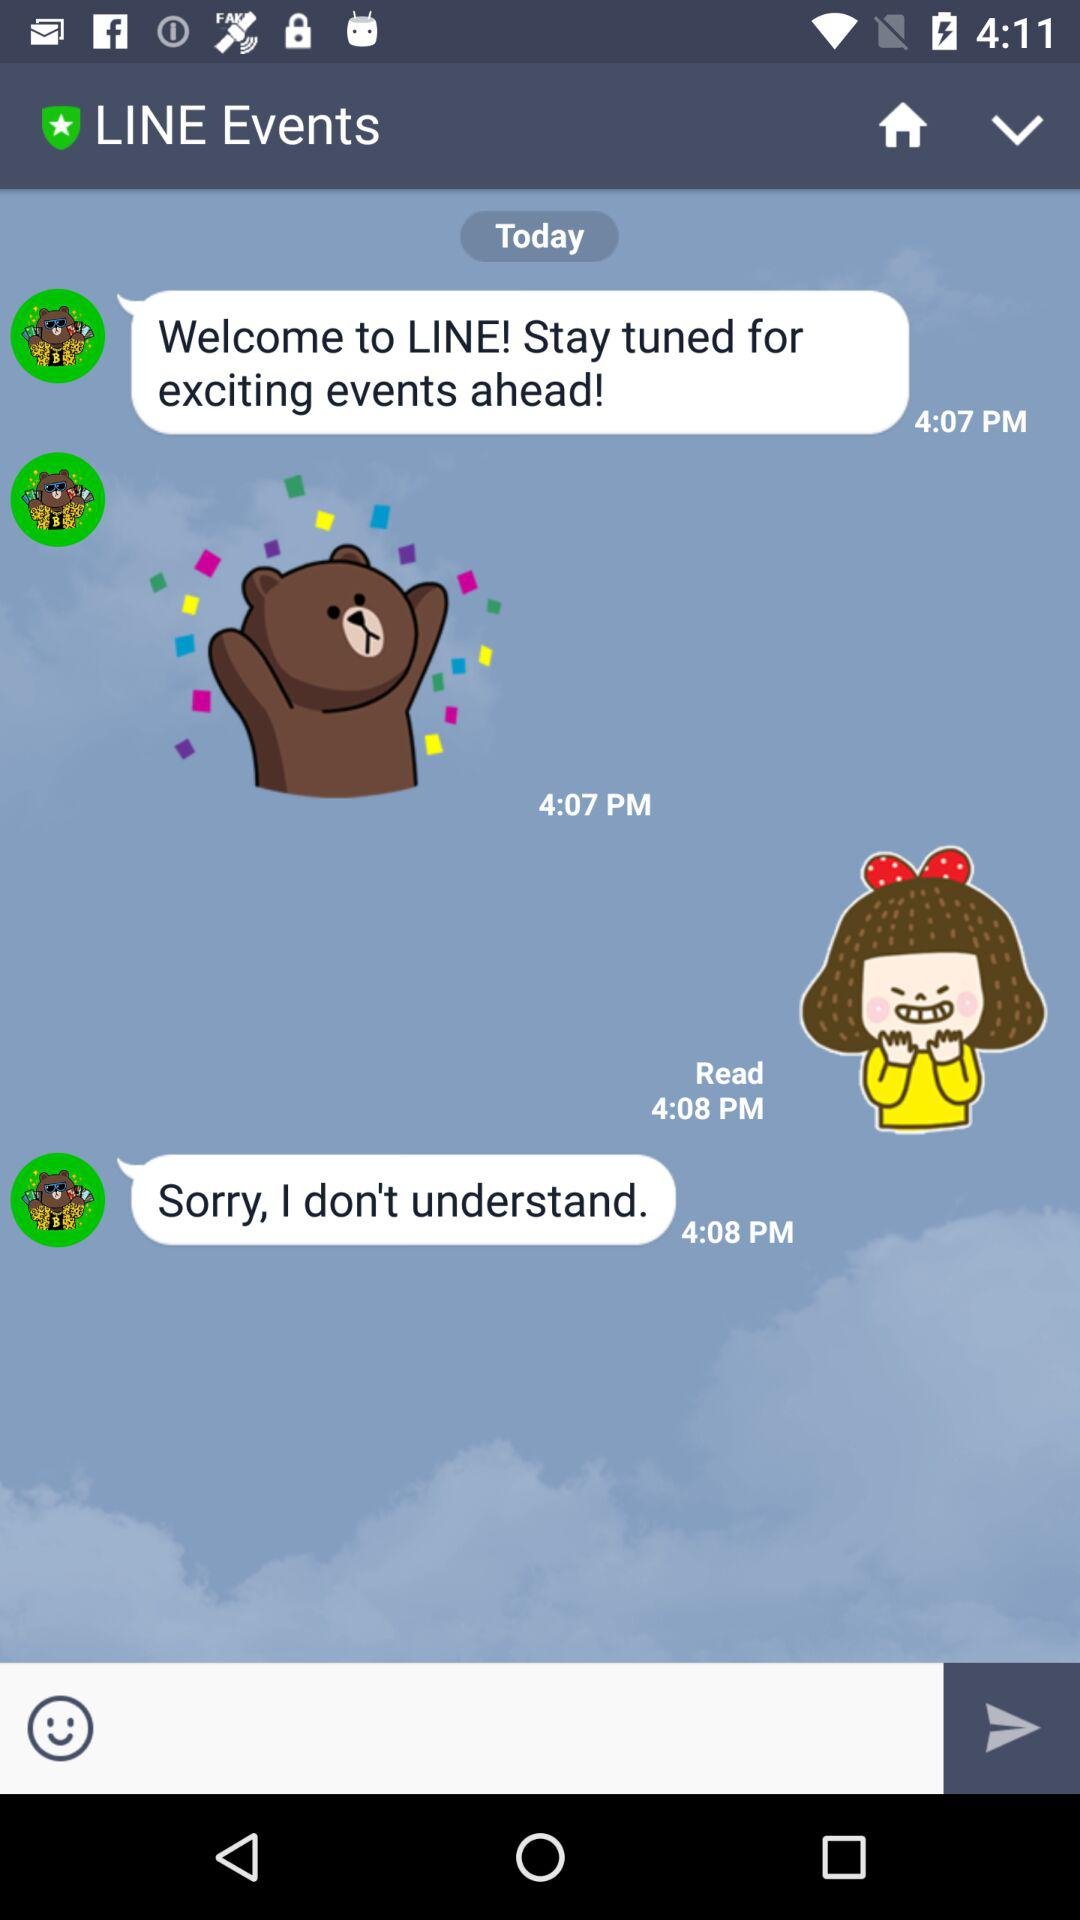Who is the user receiving the messages?
When the provided information is insufficient, respond with <no answer>. <no answer> 